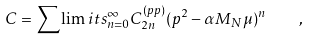<formula> <loc_0><loc_0><loc_500><loc_500>C = \sum \lim i t s _ { n = 0 } ^ { \infty } C _ { 2 n } ^ { ( p p ) } ( p ^ { 2 } - \alpha M _ { N } \mu ) ^ { n } \quad ,</formula> 